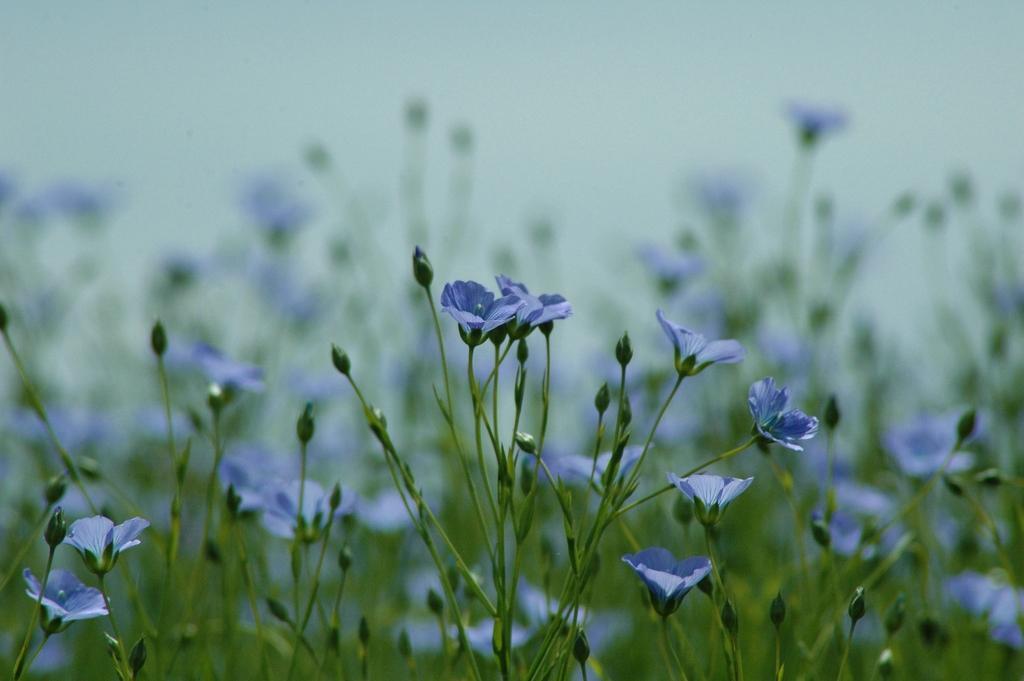Describe this image in one or two sentences. In this picture, we see plants. These plants have buds and flowers. These flowers are in violet color. At the top, we see the sky. This picture is blurred in the background. 